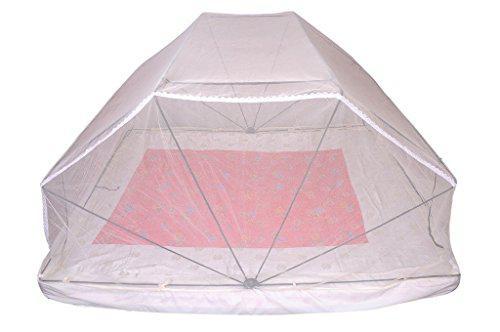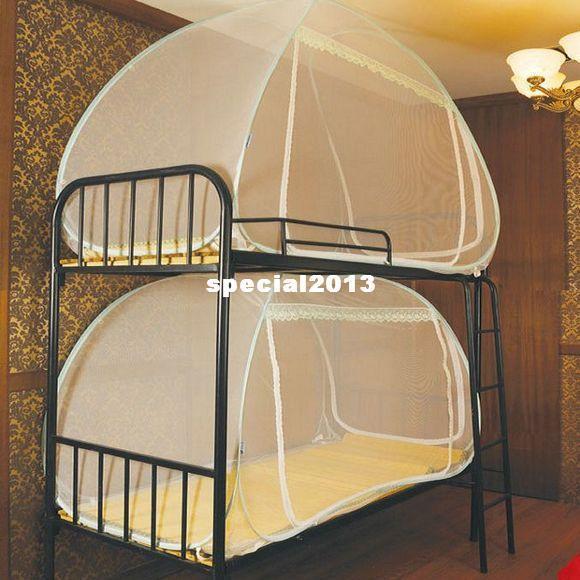The first image is the image on the left, the second image is the image on the right. For the images shown, is this caption "Two or more pillows are visible." true? Answer yes or no. No. The first image is the image on the left, the second image is the image on the right. Considering the images on both sides, is "There are two pillows in the right image." valid? Answer yes or no. No. 